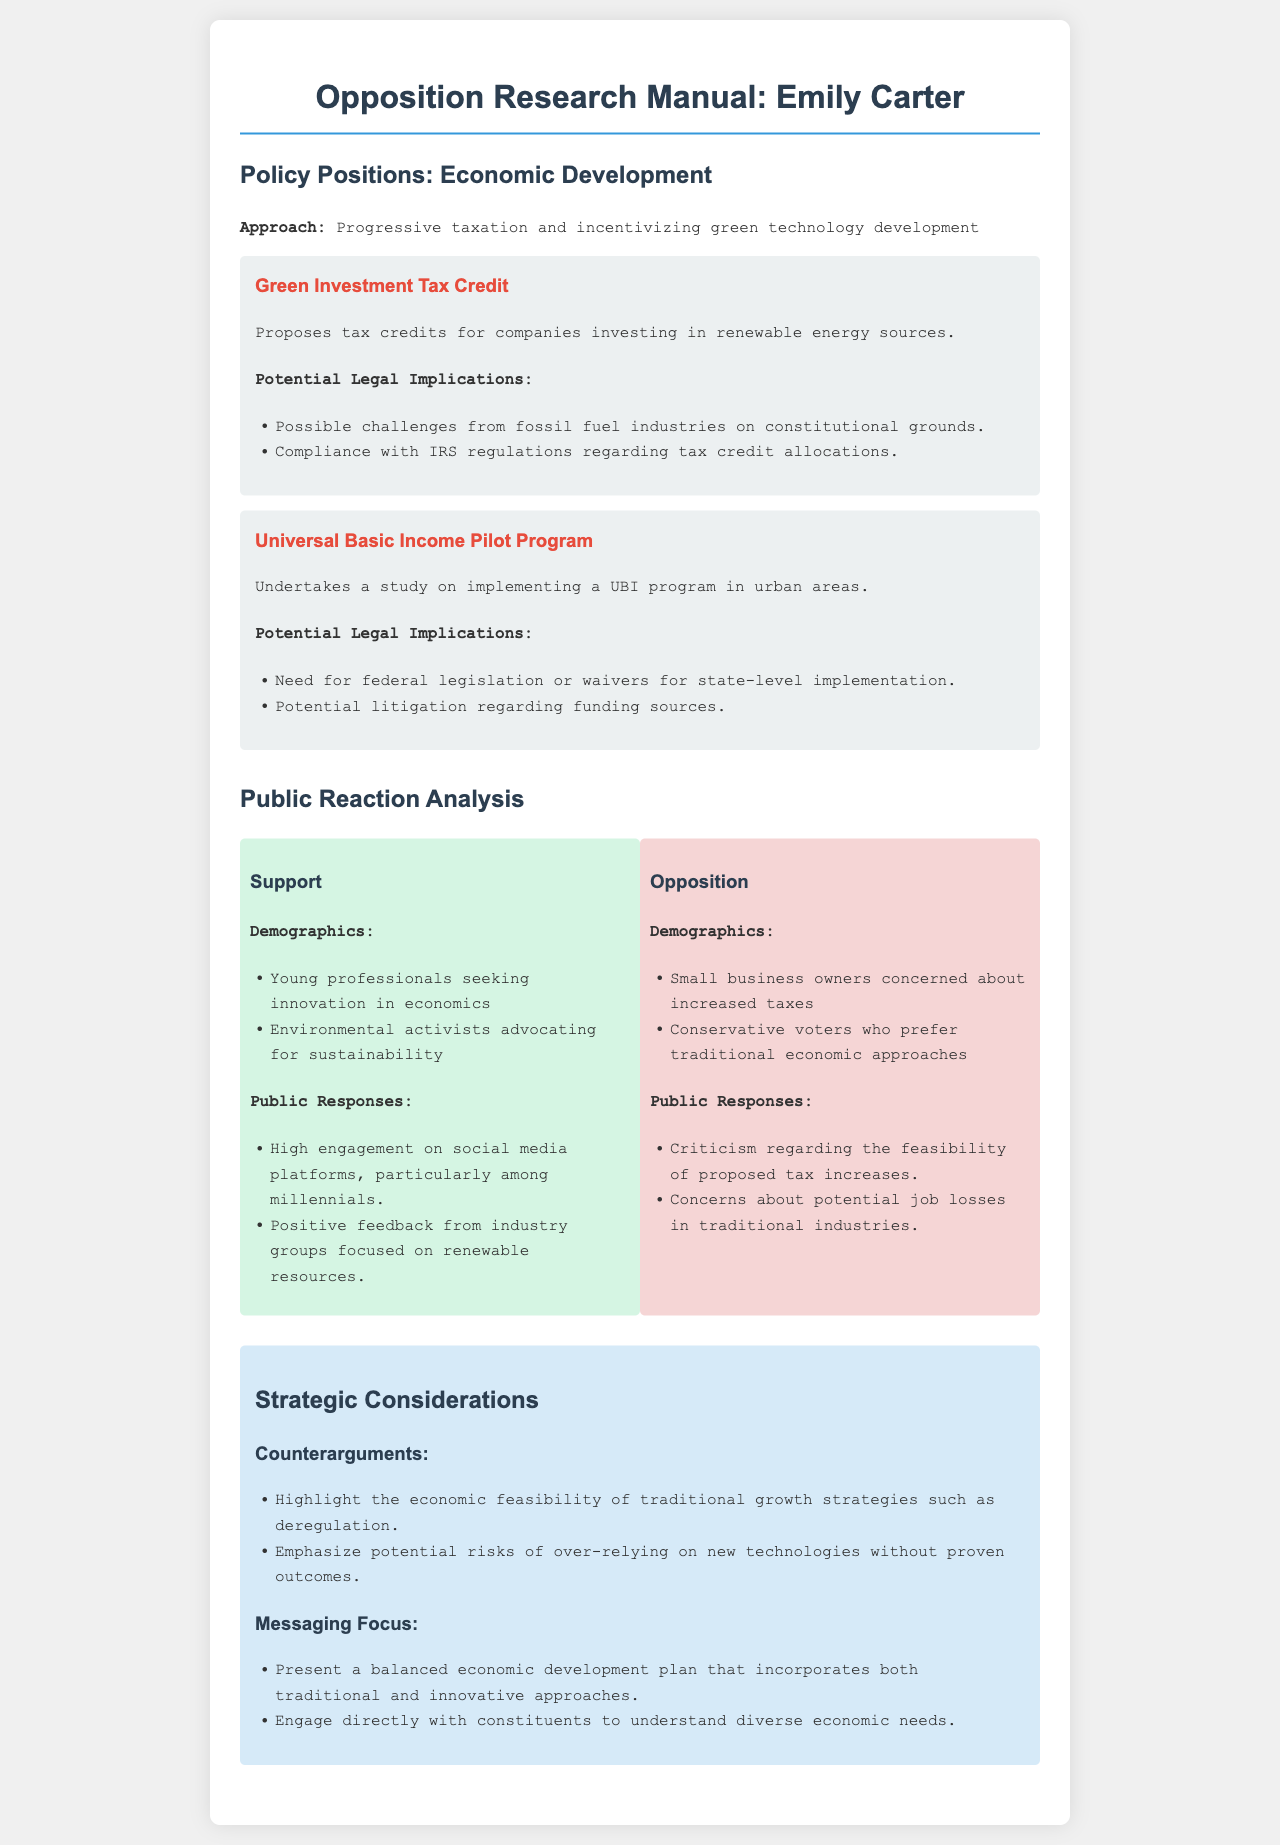What is Emily Carter's approach to economic development? The approach to economic development mentioned in the document is "Progressive taxation and incentivizing green technology development."
Answer: Progressive taxation and incentivizing green technology development What is the proposed tax credit for companies? The document mentions a "Green Investment Tax Credit" which proposes tax credits for companies investing in renewable energy sources.
Answer: Green Investment Tax Credit What demographic is listed as part of the support for Carter's policies? Young professionals seeking innovation in economics are identified as a demographic supporting Carter's policies.
Answer: Young professionals seeking innovation in economics What are small business owners concerned about? According to the document, small business owners are concerned about "increased taxes."
Answer: Increased taxes What does Carter undertake regarding Universal Basic Income? The document states she undertakes a study on implementing a UBI program.
Answer: A study on implementing a UBI program What are potential challenges related to the Green Investment Tax Credit? The potential challenges listed include "Possible challenges from fossil fuel industries on constitutional grounds."
Answer: Possible challenges from fossil fuel industries on constitutional grounds What type of voters prefer traditional economic approaches? The document specifies "Conservative voters" as those who prefer traditional economic approaches.
Answer: Conservative voters What is a suggested counterargument in the strategic considerations? The document suggests a counterargument that emphasizes the "economic feasibility of traditional growth strategies such as deregulation."
Answer: Economic feasibility of traditional growth strategies such as deregulation 